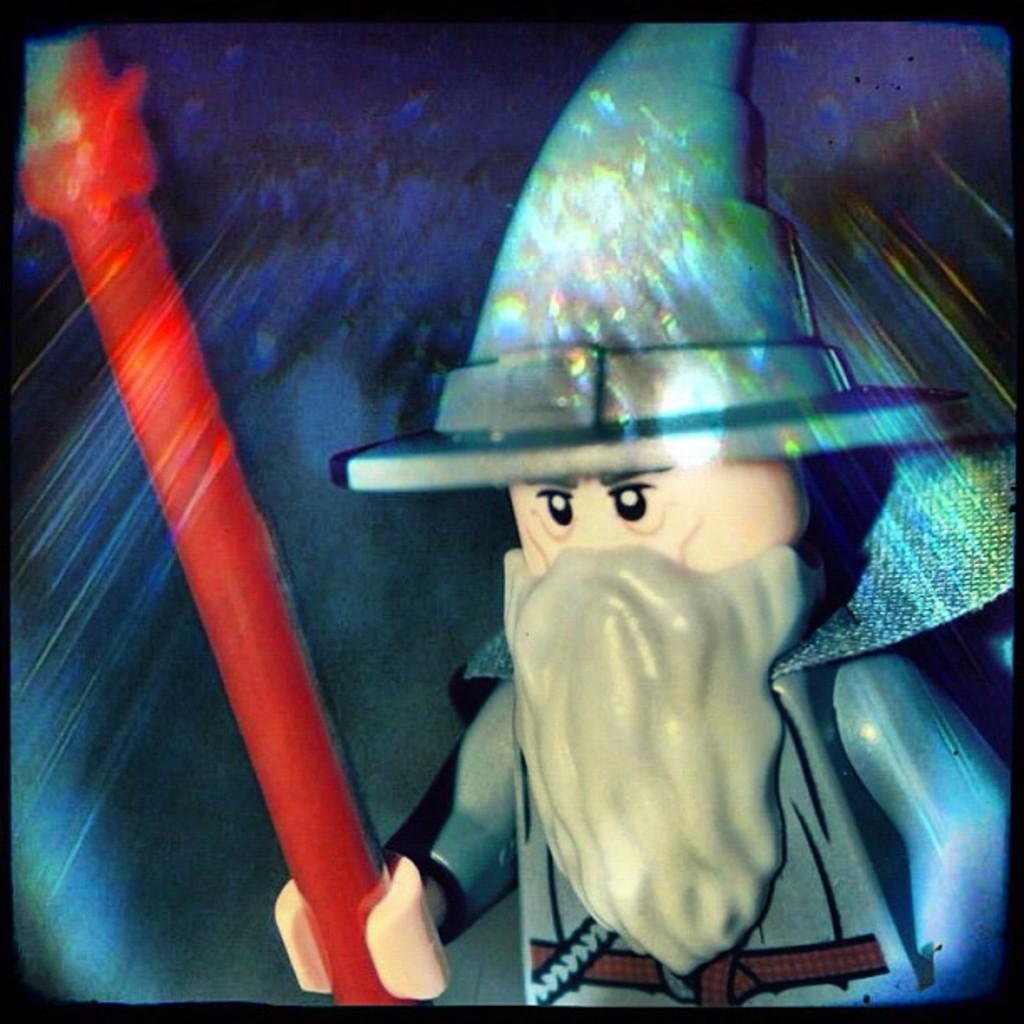How would you summarize this image in a sentence or two? This is an animated image. We can see a person holding some object. 